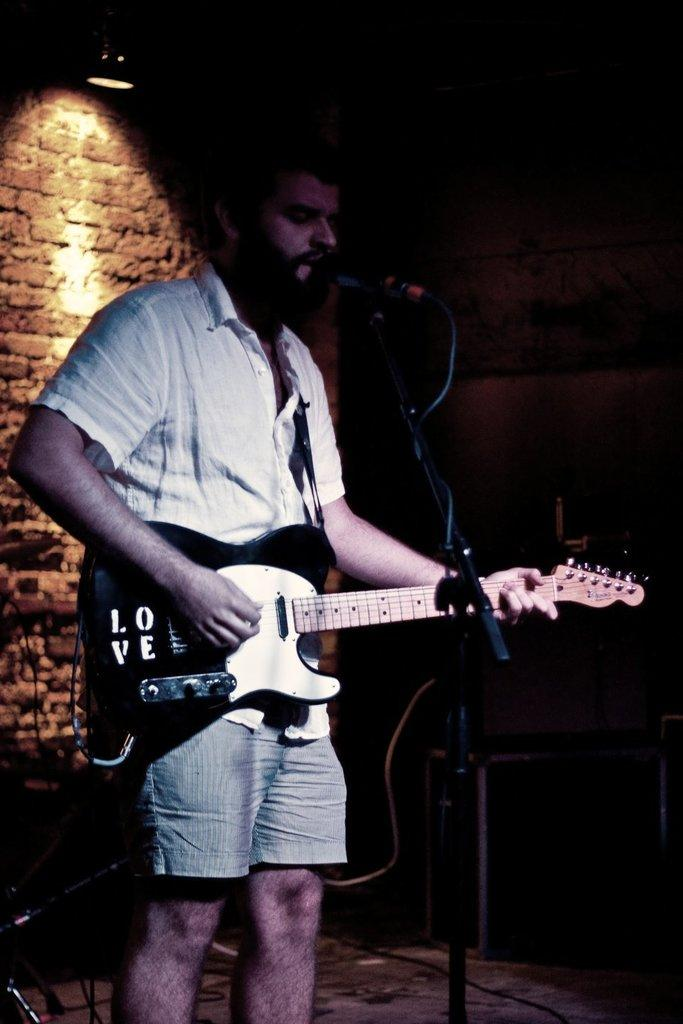What is the person in the image doing? The person is playing the guitar. What object is in front of the person? There is a microphone in front of the person. What can be seen in the background of the image? There are musical instruments in the background. How would you describe the lighting in the image? The background is dark. What type of thread is being used to play the guitar in the image? There is no thread being used to play the guitar in the image; the person is using their hands to play the instrument. 